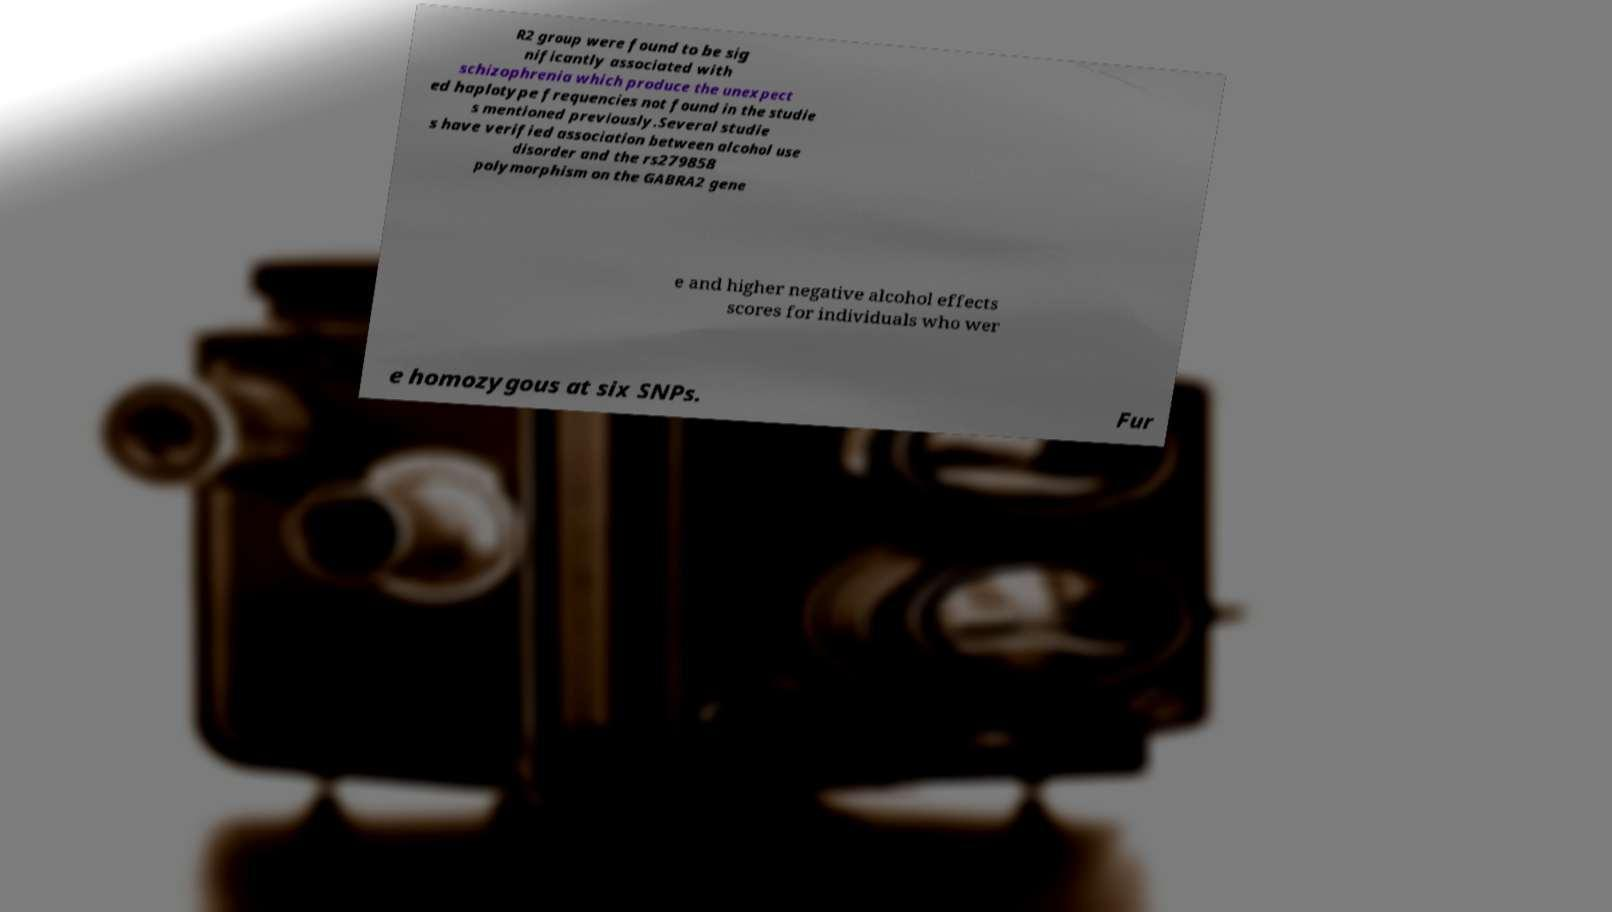Can you accurately transcribe the text from the provided image for me? R2 group were found to be sig nificantly associated with schizophrenia which produce the unexpect ed haplotype frequencies not found in the studie s mentioned previously.Several studie s have verified association between alcohol use disorder and the rs279858 polymorphism on the GABRA2 gene e and higher negative alcohol effects scores for individuals who wer e homozygous at six SNPs. Fur 